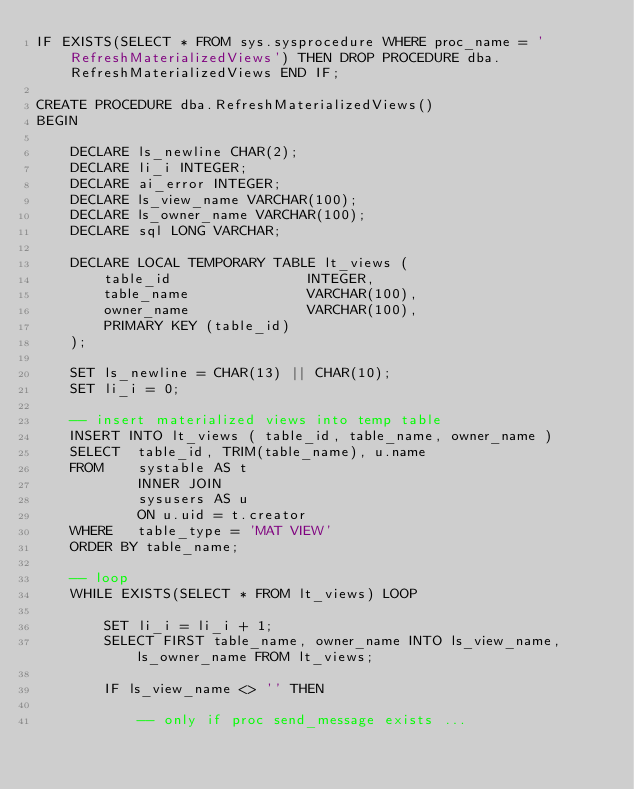Convert code to text. <code><loc_0><loc_0><loc_500><loc_500><_SQL_>IF EXISTS(SELECT * FROM sys.sysprocedure WHERE proc_name = 'RefreshMaterializedViews') THEN DROP PROCEDURE dba.RefreshMaterializedViews END IF;

CREATE PROCEDURE dba.RefreshMaterializedViews()
BEGIN

    DECLARE ls_newline CHAR(2);
    DECLARE li_i INTEGER;
    DECLARE ai_error INTEGER;
    DECLARE ls_view_name VARCHAR(100);
    DECLARE ls_owner_name VARCHAR(100);
    DECLARE sql LONG VARCHAR;

    DECLARE LOCAL TEMPORARY TABLE lt_views (
        table_id                INTEGER,
        table_name              VARCHAR(100),
        owner_name              VARCHAR(100),
        PRIMARY KEY (table_id)
    );

    SET ls_newline = CHAR(13) || CHAR(10);
    SET li_i = 0;

    -- insert materialized views into temp table
    INSERT INTO lt_views ( table_id, table_name, owner_name )
    SELECT  table_id, TRIM(table_name), u.name
    FROM    systable AS t
            INNER JOIN
            sysusers AS u
            ON u.uid = t.creator
    WHERE   table_type = 'MAT VIEW'
    ORDER BY table_name;

    -- loop
    WHILE EXISTS(SELECT * FROM lt_views) LOOP

        SET li_i = li_i + 1;
        SELECT FIRST table_name, owner_name INTO ls_view_name, ls_owner_name FROM lt_views;

        IF ls_view_name <> '' THEN

            -- only if proc send_message exists ...</code> 